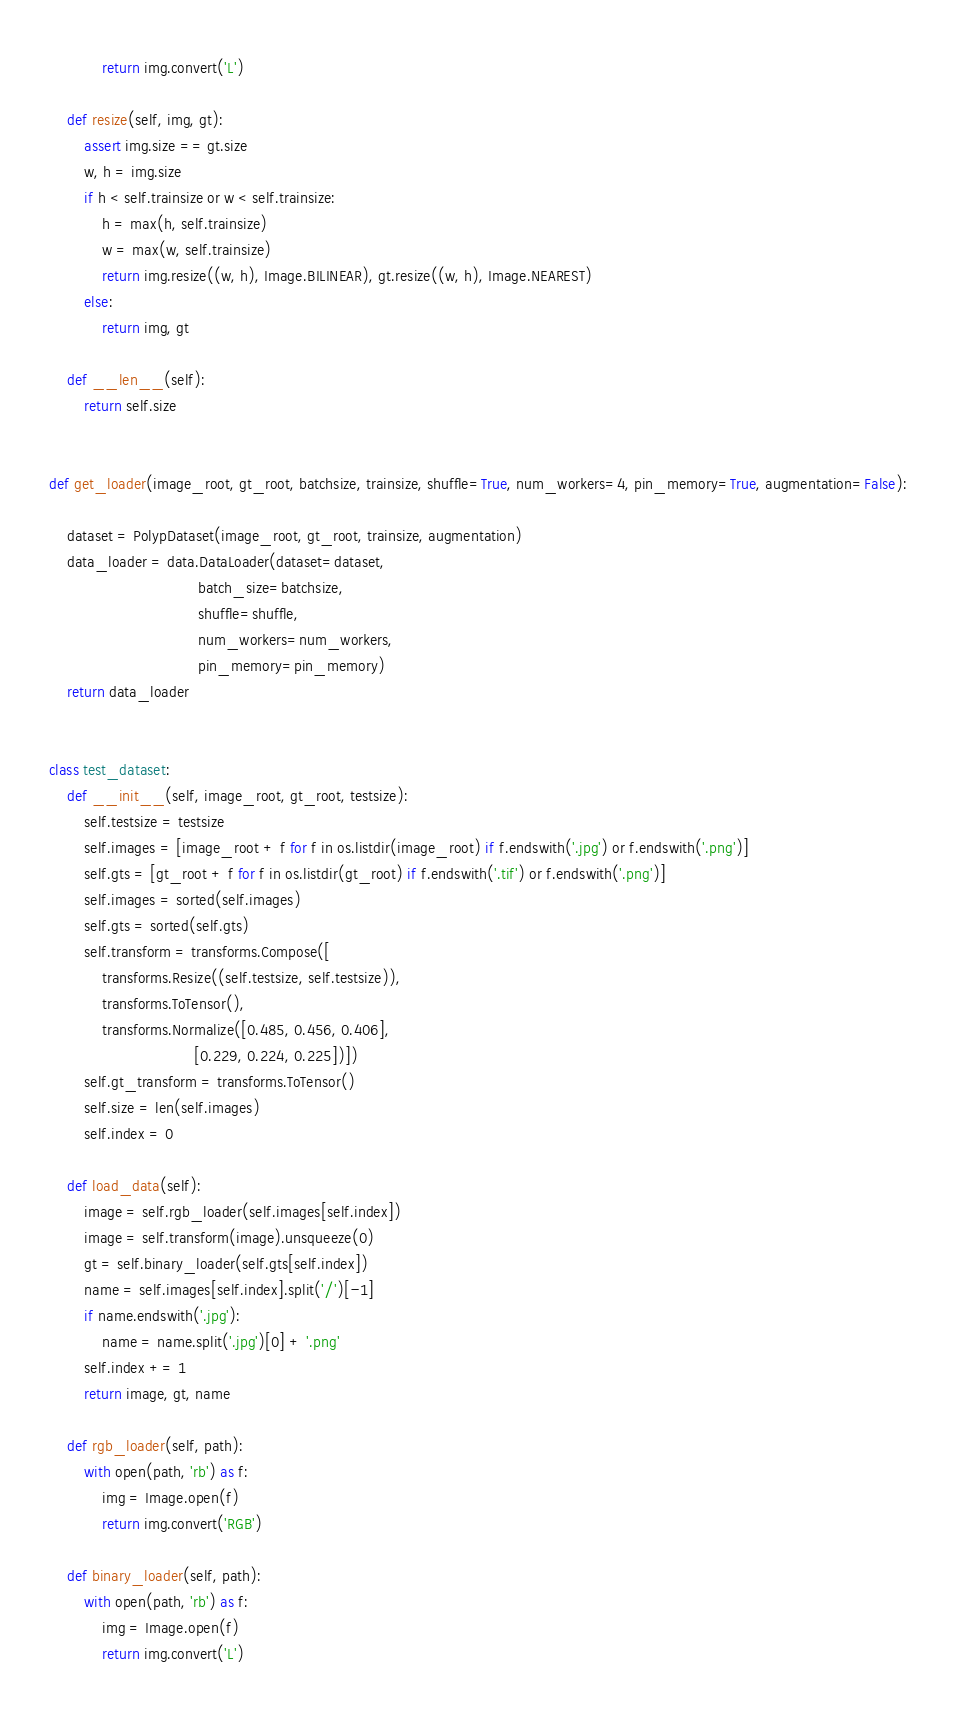<code> <loc_0><loc_0><loc_500><loc_500><_Python_>            return img.convert('L')

    def resize(self, img, gt):
        assert img.size == gt.size
        w, h = img.size
        if h < self.trainsize or w < self.trainsize:
            h = max(h, self.trainsize)
            w = max(w, self.trainsize)
            return img.resize((w, h), Image.BILINEAR), gt.resize((w, h), Image.NEAREST)
        else:
            return img, gt

    def __len__(self):
        return self.size


def get_loader(image_root, gt_root, batchsize, trainsize, shuffle=True, num_workers=4, pin_memory=True, augmentation=False):

    dataset = PolypDataset(image_root, gt_root, trainsize, augmentation)
    data_loader = data.DataLoader(dataset=dataset,
                                  batch_size=batchsize,
                                  shuffle=shuffle,
                                  num_workers=num_workers,
                                  pin_memory=pin_memory)
    return data_loader


class test_dataset:
    def __init__(self, image_root, gt_root, testsize):
        self.testsize = testsize
        self.images = [image_root + f for f in os.listdir(image_root) if f.endswith('.jpg') or f.endswith('.png')]
        self.gts = [gt_root + f for f in os.listdir(gt_root) if f.endswith('.tif') or f.endswith('.png')]
        self.images = sorted(self.images)
        self.gts = sorted(self.gts)
        self.transform = transforms.Compose([
            transforms.Resize((self.testsize, self.testsize)),
            transforms.ToTensor(),
            transforms.Normalize([0.485, 0.456, 0.406],
                                 [0.229, 0.224, 0.225])])
        self.gt_transform = transforms.ToTensor()
        self.size = len(self.images)
        self.index = 0

    def load_data(self):
        image = self.rgb_loader(self.images[self.index])
        image = self.transform(image).unsqueeze(0)
        gt = self.binary_loader(self.gts[self.index])
        name = self.images[self.index].split('/')[-1]
        if name.endswith('.jpg'):
            name = name.split('.jpg')[0] + '.png'
        self.index += 1
        return image, gt, name

    def rgb_loader(self, path):
        with open(path, 'rb') as f:
            img = Image.open(f)
            return img.convert('RGB')

    def binary_loader(self, path):
        with open(path, 'rb') as f:
            img = Image.open(f)
            return img.convert('L')
</code> 